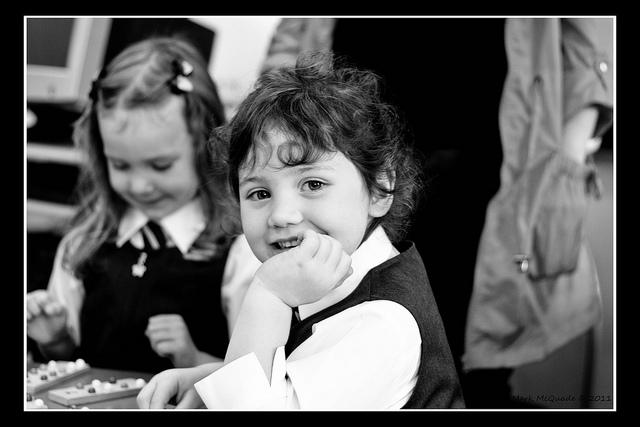Are these people young?
Concise answer only. Yes. Why is there no color?
Be succinct. Black and white. What color is this kids vest?
Concise answer only. Black. 